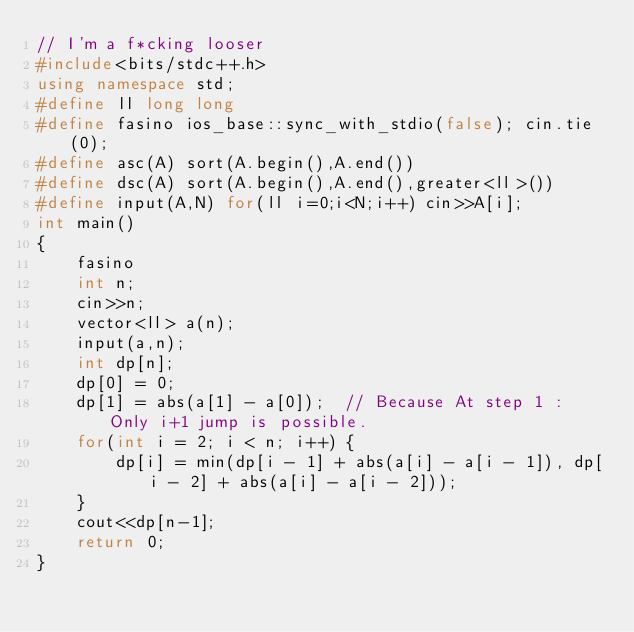<code> <loc_0><loc_0><loc_500><loc_500><_C++_>// I'm a f*cking looser
#include<bits/stdc++.h>
using namespace std;
#define ll long long
#define fasino ios_base::sync_with_stdio(false); cin.tie(0);
#define asc(A) sort(A.begin(),A.end())
#define dsc(A) sort(A.begin(),A.end(),greater<ll>())
#define input(A,N) for(ll i=0;i<N;i++) cin>>A[i];
int main()
{
    fasino
    int n;
    cin>>n;
    vector<ll> a(n);
    input(a,n);
    int dp[n];
    dp[0] = 0;
    dp[1] = abs(a[1] - a[0]);  // Because At step 1 : Only i+1 jump is possible.
    for(int i = 2; i < n; i++) {
        dp[i] = min(dp[i - 1] + abs(a[i] - a[i - 1]), dp[i - 2] + abs(a[i] - a[i - 2]));
    }
    cout<<dp[n-1];
    return 0;
}</code> 